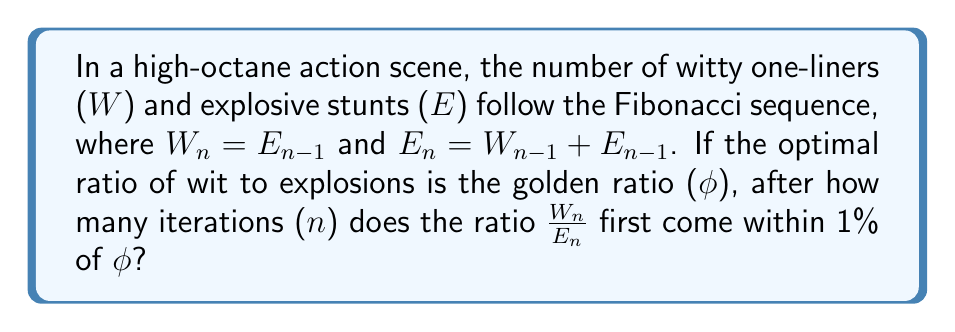Can you answer this question? Let's approach this step-by-step:

1) The golden ratio $\phi = \frac{1 + \sqrt{5}}{2} \approx 1.618033989$

2) The Fibonacci sequence for W and E will be:
   W: 0, 1, 1, 2, 3, 5, 8, 13, 21, 34, ...
   E: 1, 1, 2, 3, 5, 8, 13, 21, 34, 55, ...

3) The ratio $\frac{W_n}{E_n}$ will approach $\phi$ as n increases.

4) We need to find n where $|\frac{W_n}{E_n} - \phi| < 0.01\phi$

5) Let's calculate the ratios:
   n=1: $\frac{0}{1} = 0$
   n=2: $\frac{1}{1} = 1$
   n=3: $\frac{1}{2} = 0.5$
   n=4: $\frac{2}{3} \approx 0.6667$
   n=5: $\frac{3}{5} = 0.6$
   n=6: $\frac{5}{8} = 0.625$
   n=7: $\frac{8}{13} \approx 0.6154$
   n=8: $\frac{13}{21} \approx 0.6190$
   n=9: $\frac{21}{34} \approx 0.6176$
   n=10: $\frac{34}{55} \approx 0.6182$
   n=11: $\frac{55}{89} \approx 0.6180$

6) At n=11, $|\frac{55}{89} - \phi| \approx 0.0000339 < 0.01\phi \approx 0.01618$

Therefore, the ratio first comes within 1% of $\phi$ after 11 iterations.
Answer: 11 